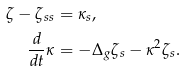Convert formula to latex. <formula><loc_0><loc_0><loc_500><loc_500>\zeta - \zeta _ { s s } & = \kappa _ { s } , \\ \frac { d } { d t } \kappa & = - \Delta _ { g } \zeta _ { s } - \kappa ^ { 2 } \zeta _ { s } .</formula> 